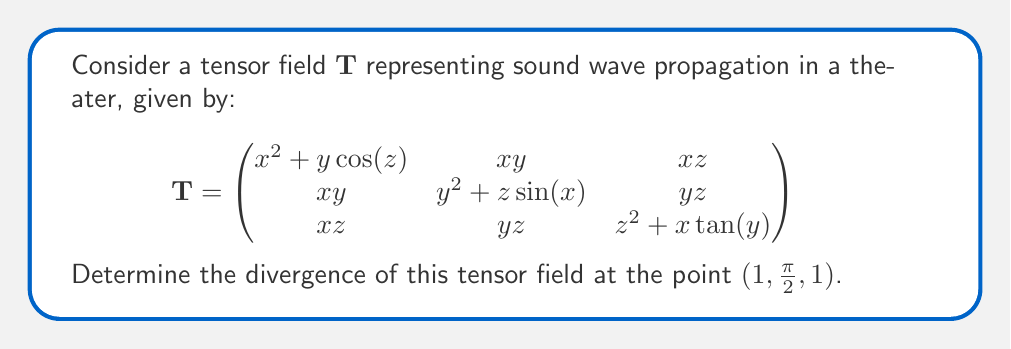What is the answer to this math problem? To find the divergence of a tensor field, we need to sum the partial derivatives of the diagonal elements with respect to their corresponding variables. The divergence is given by:

$$\text{div}(\mathbf{T}) = \frac{\partial T_{11}}{\partial x} + \frac{\partial T_{22}}{\partial y} + \frac{\partial T_{33}}{\partial z}$$

Let's calculate each term:

1) $\frac{\partial T_{11}}{\partial x}$:
   $T_{11} = x^2 + y\cos(z)$
   $\frac{\partial T_{11}}{\partial x} = 2x$
   At $(1, \frac{\pi}{2}, 1)$: $\frac{\partial T_{11}}{\partial x} = 2(1) = 2$

2) $\frac{\partial T_{22}}{\partial y}$:
   $T_{22} = y^2 + z\sin(x)$
   $\frac{\partial T_{22}}{\partial y} = 2y$
   At $(1, \frac{\pi}{2}, 1)$: $\frac{\partial T_{22}}{\partial y} = 2(\frac{\pi}{2}) = \pi$

3) $\frac{\partial T_{33}}{\partial z}$:
   $T_{33} = z^2 + x\tan(y)$
   $\frac{\partial T_{33}}{\partial z} = 2z$
   At $(1, \frac{\pi}{2}, 1)$: $\frac{\partial T_{33}}{\partial z} = 2(1) = 2$

Now, we sum these terms:

$$\text{div}(\mathbf{T}) = 2 + \pi + 2 = 4 + \pi$$

This is the divergence of the tensor field at the point $(1, \frac{\pi}{2}, 1)$.
Answer: $4 + \pi$ 